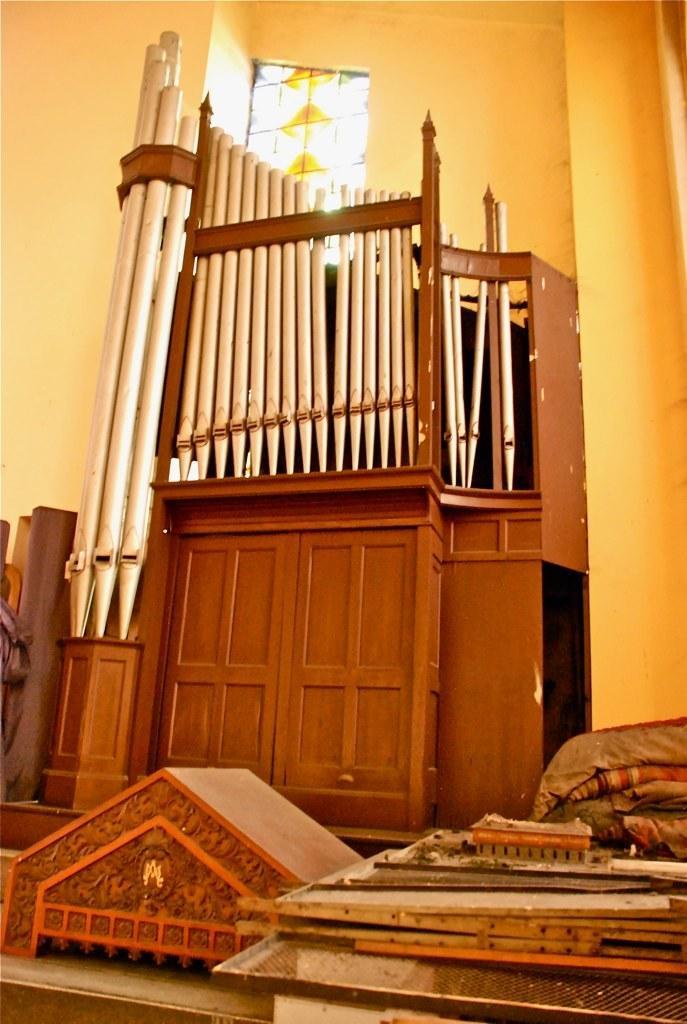Please provide a concise description of this image. In this picture there is a wooden door in the center of the image and there are wooden boards at the bottom side of the image, there is a window at the top side of the image. 